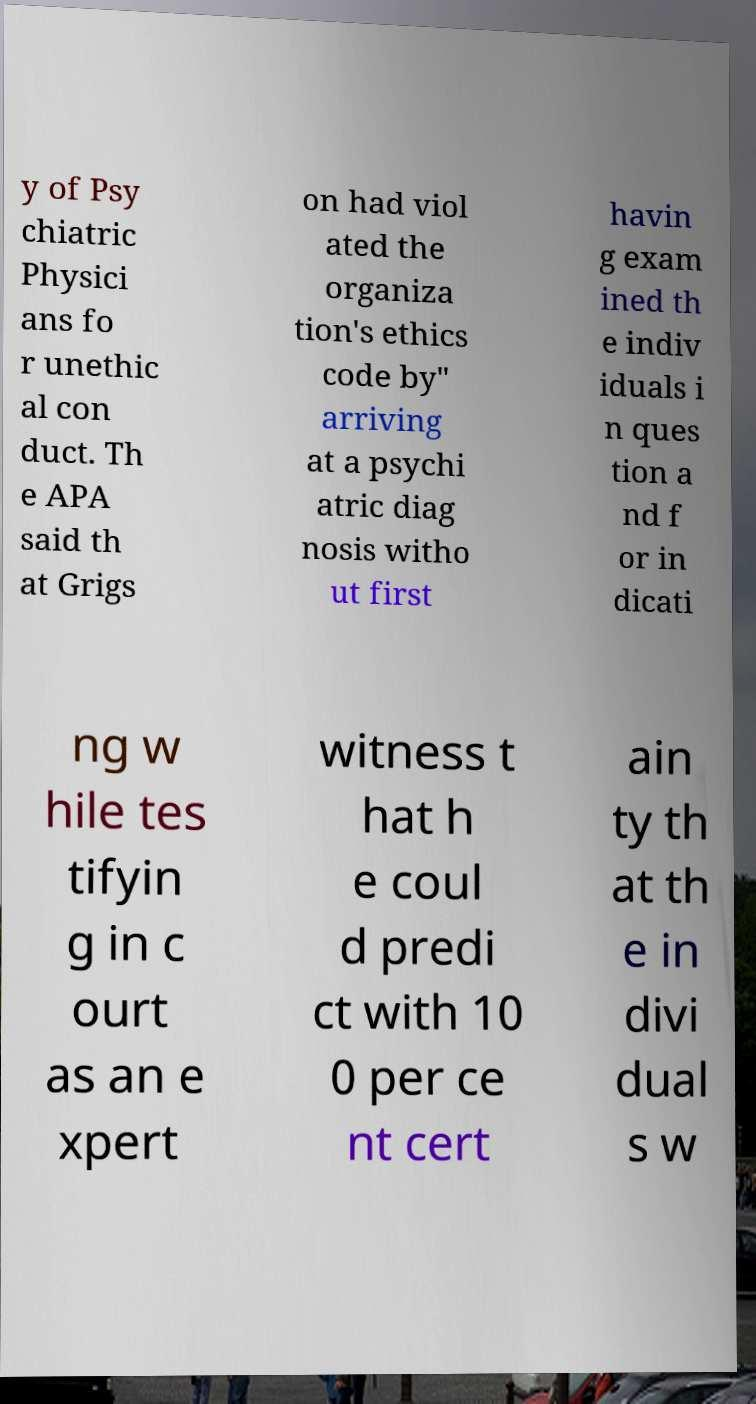What messages or text are displayed in this image? I need them in a readable, typed format. y of Psy chiatric Physici ans fo r unethic al con duct. Th e APA said th at Grigs on had viol ated the organiza tion's ethics code by" arriving at a psychi atric diag nosis witho ut first havin g exam ined th e indiv iduals i n ques tion a nd f or in dicati ng w hile tes tifyin g in c ourt as an e xpert witness t hat h e coul d predi ct with 10 0 per ce nt cert ain ty th at th e in divi dual s w 